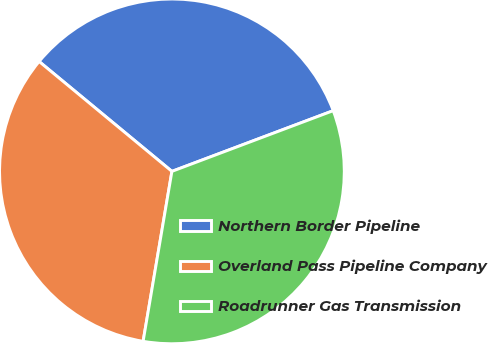<chart> <loc_0><loc_0><loc_500><loc_500><pie_chart><fcel>Northern Border Pipeline<fcel>Overland Pass Pipeline Company<fcel>Roadrunner Gas Transmission<nl><fcel>33.27%<fcel>33.33%<fcel>33.4%<nl></chart> 